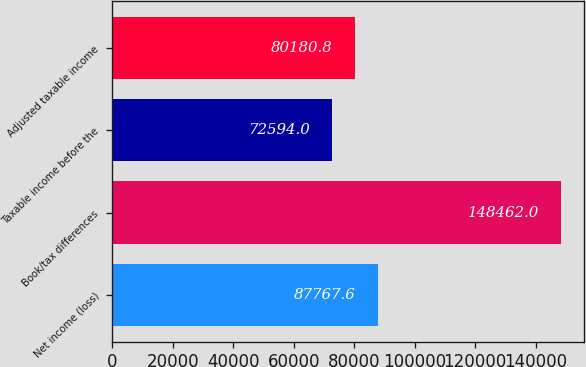Convert chart to OTSL. <chart><loc_0><loc_0><loc_500><loc_500><bar_chart><fcel>Net income (loss)<fcel>Book/tax differences<fcel>Taxable income before the<fcel>Adjusted taxable income<nl><fcel>87767.6<fcel>148462<fcel>72594<fcel>80180.8<nl></chart> 